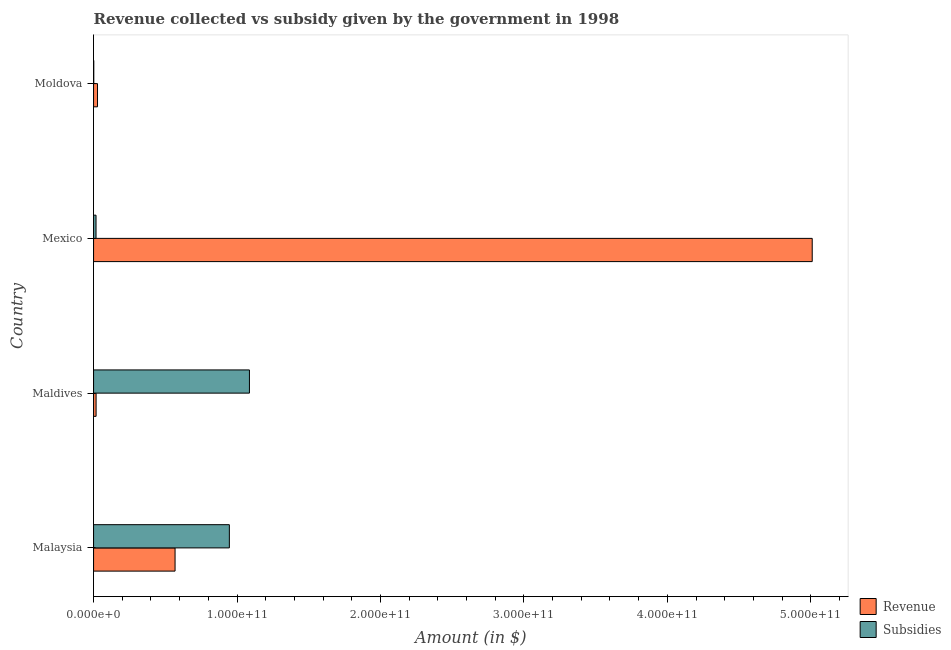How many different coloured bars are there?
Ensure brevity in your answer.  2. How many groups of bars are there?
Ensure brevity in your answer.  4. Are the number of bars per tick equal to the number of legend labels?
Provide a short and direct response. Yes. Are the number of bars on each tick of the Y-axis equal?
Your answer should be compact. Yes. How many bars are there on the 3rd tick from the top?
Your response must be concise. 2. What is the label of the 4th group of bars from the top?
Your response must be concise. Malaysia. What is the amount of revenue collected in Malaysia?
Keep it short and to the point. 5.68e+1. Across all countries, what is the maximum amount of revenue collected?
Your answer should be very brief. 5.01e+11. Across all countries, what is the minimum amount of revenue collected?
Offer a very short reply. 1.76e+09. In which country was the amount of revenue collected maximum?
Your answer should be very brief. Mexico. In which country was the amount of subsidies given minimum?
Make the answer very short. Moldova. What is the total amount of revenue collected in the graph?
Give a very brief answer. 5.62e+11. What is the difference between the amount of revenue collected in Mexico and that in Moldova?
Offer a very short reply. 4.98e+11. What is the difference between the amount of subsidies given in Mexico and the amount of revenue collected in Maldives?
Your response must be concise. -3.92e+07. What is the average amount of subsidies given per country?
Keep it short and to the point. 5.13e+1. What is the difference between the amount of subsidies given and amount of revenue collected in Malaysia?
Offer a very short reply. 3.78e+1. In how many countries, is the amount of subsidies given greater than 280000000000 $?
Offer a terse response. 0. What is the ratio of the amount of subsidies given in Malaysia to that in Mexico?
Offer a terse response. 54.9. What is the difference between the highest and the second highest amount of revenue collected?
Make the answer very short. 4.44e+11. What is the difference between the highest and the lowest amount of revenue collected?
Ensure brevity in your answer.  4.99e+11. What does the 1st bar from the top in Moldova represents?
Offer a terse response. Subsidies. What does the 2nd bar from the bottom in Malaysia represents?
Offer a very short reply. Subsidies. Are all the bars in the graph horizontal?
Make the answer very short. Yes. What is the difference between two consecutive major ticks on the X-axis?
Keep it short and to the point. 1.00e+11. Are the values on the major ticks of X-axis written in scientific E-notation?
Keep it short and to the point. Yes. Does the graph contain any zero values?
Offer a terse response. No. How many legend labels are there?
Make the answer very short. 2. What is the title of the graph?
Your response must be concise. Revenue collected vs subsidy given by the government in 1998. What is the label or title of the X-axis?
Your response must be concise. Amount (in $). What is the label or title of the Y-axis?
Give a very brief answer. Country. What is the Amount (in $) of Revenue in Malaysia?
Your answer should be very brief. 5.68e+1. What is the Amount (in $) in Subsidies in Malaysia?
Provide a short and direct response. 9.47e+1. What is the Amount (in $) of Revenue in Maldives?
Keep it short and to the point. 1.76e+09. What is the Amount (in $) of Subsidies in Maldives?
Make the answer very short. 1.09e+11. What is the Amount (in $) in Revenue in Mexico?
Provide a short and direct response. 5.01e+11. What is the Amount (in $) of Subsidies in Mexico?
Offer a very short reply. 1.72e+09. What is the Amount (in $) in Revenue in Moldova?
Provide a short and direct response. 2.76e+09. What is the Amount (in $) of Subsidies in Moldova?
Make the answer very short. 1.45e+08. Across all countries, what is the maximum Amount (in $) in Revenue?
Keep it short and to the point. 5.01e+11. Across all countries, what is the maximum Amount (in $) of Subsidies?
Keep it short and to the point. 1.09e+11. Across all countries, what is the minimum Amount (in $) of Revenue?
Your response must be concise. 1.76e+09. Across all countries, what is the minimum Amount (in $) in Subsidies?
Make the answer very short. 1.45e+08. What is the total Amount (in $) of Revenue in the graph?
Make the answer very short. 5.62e+11. What is the total Amount (in $) of Subsidies in the graph?
Your answer should be very brief. 2.05e+11. What is the difference between the Amount (in $) in Revenue in Malaysia and that in Maldives?
Provide a short and direct response. 5.51e+1. What is the difference between the Amount (in $) in Subsidies in Malaysia and that in Maldives?
Give a very brief answer. -1.40e+1. What is the difference between the Amount (in $) of Revenue in Malaysia and that in Mexico?
Give a very brief answer. -4.44e+11. What is the difference between the Amount (in $) of Subsidies in Malaysia and that in Mexico?
Offer a terse response. 9.29e+1. What is the difference between the Amount (in $) of Revenue in Malaysia and that in Moldova?
Ensure brevity in your answer.  5.41e+1. What is the difference between the Amount (in $) of Subsidies in Malaysia and that in Moldova?
Your answer should be compact. 9.45e+1. What is the difference between the Amount (in $) of Revenue in Maldives and that in Mexico?
Offer a very short reply. -4.99e+11. What is the difference between the Amount (in $) in Subsidies in Maldives and that in Mexico?
Ensure brevity in your answer.  1.07e+11. What is the difference between the Amount (in $) of Revenue in Maldives and that in Moldova?
Give a very brief answer. -9.92e+08. What is the difference between the Amount (in $) of Subsidies in Maldives and that in Moldova?
Keep it short and to the point. 1.09e+11. What is the difference between the Amount (in $) in Revenue in Mexico and that in Moldova?
Provide a succinct answer. 4.98e+11. What is the difference between the Amount (in $) of Subsidies in Mexico and that in Moldova?
Provide a succinct answer. 1.58e+09. What is the difference between the Amount (in $) in Revenue in Malaysia and the Amount (in $) in Subsidies in Maldives?
Provide a succinct answer. -5.18e+1. What is the difference between the Amount (in $) of Revenue in Malaysia and the Amount (in $) of Subsidies in Mexico?
Provide a short and direct response. 5.51e+1. What is the difference between the Amount (in $) of Revenue in Malaysia and the Amount (in $) of Subsidies in Moldova?
Keep it short and to the point. 5.67e+1. What is the difference between the Amount (in $) of Revenue in Maldives and the Amount (in $) of Subsidies in Mexico?
Offer a very short reply. 3.92e+07. What is the difference between the Amount (in $) in Revenue in Maldives and the Amount (in $) in Subsidies in Moldova?
Provide a short and direct response. 1.62e+09. What is the difference between the Amount (in $) in Revenue in Mexico and the Amount (in $) in Subsidies in Moldova?
Your answer should be very brief. 5.01e+11. What is the average Amount (in $) of Revenue per country?
Provide a short and direct response. 1.41e+11. What is the average Amount (in $) of Subsidies per country?
Keep it short and to the point. 5.13e+1. What is the difference between the Amount (in $) in Revenue and Amount (in $) in Subsidies in Malaysia?
Your answer should be very brief. -3.78e+1. What is the difference between the Amount (in $) of Revenue and Amount (in $) of Subsidies in Maldives?
Ensure brevity in your answer.  -1.07e+11. What is the difference between the Amount (in $) in Revenue and Amount (in $) in Subsidies in Mexico?
Your response must be concise. 4.99e+11. What is the difference between the Amount (in $) in Revenue and Amount (in $) in Subsidies in Moldova?
Provide a succinct answer. 2.61e+09. What is the ratio of the Amount (in $) of Revenue in Malaysia to that in Maldives?
Ensure brevity in your answer.  32.22. What is the ratio of the Amount (in $) in Subsidies in Malaysia to that in Maldives?
Offer a very short reply. 0.87. What is the ratio of the Amount (in $) of Revenue in Malaysia to that in Mexico?
Provide a succinct answer. 0.11. What is the ratio of the Amount (in $) of Subsidies in Malaysia to that in Mexico?
Provide a short and direct response. 54.9. What is the ratio of the Amount (in $) in Revenue in Malaysia to that in Moldova?
Provide a short and direct response. 20.62. What is the ratio of the Amount (in $) of Subsidies in Malaysia to that in Moldova?
Ensure brevity in your answer.  651.56. What is the ratio of the Amount (in $) of Revenue in Maldives to that in Mexico?
Your answer should be very brief. 0. What is the ratio of the Amount (in $) in Subsidies in Maldives to that in Mexico?
Provide a short and direct response. 63.02. What is the ratio of the Amount (in $) in Revenue in Maldives to that in Moldova?
Your answer should be very brief. 0.64. What is the ratio of the Amount (in $) in Subsidies in Maldives to that in Moldova?
Offer a terse response. 747.9. What is the ratio of the Amount (in $) in Revenue in Mexico to that in Moldova?
Give a very brief answer. 181.82. What is the ratio of the Amount (in $) of Subsidies in Mexico to that in Moldova?
Your answer should be compact. 11.87. What is the difference between the highest and the second highest Amount (in $) in Revenue?
Give a very brief answer. 4.44e+11. What is the difference between the highest and the second highest Amount (in $) of Subsidies?
Offer a terse response. 1.40e+1. What is the difference between the highest and the lowest Amount (in $) of Revenue?
Keep it short and to the point. 4.99e+11. What is the difference between the highest and the lowest Amount (in $) of Subsidies?
Your answer should be very brief. 1.09e+11. 